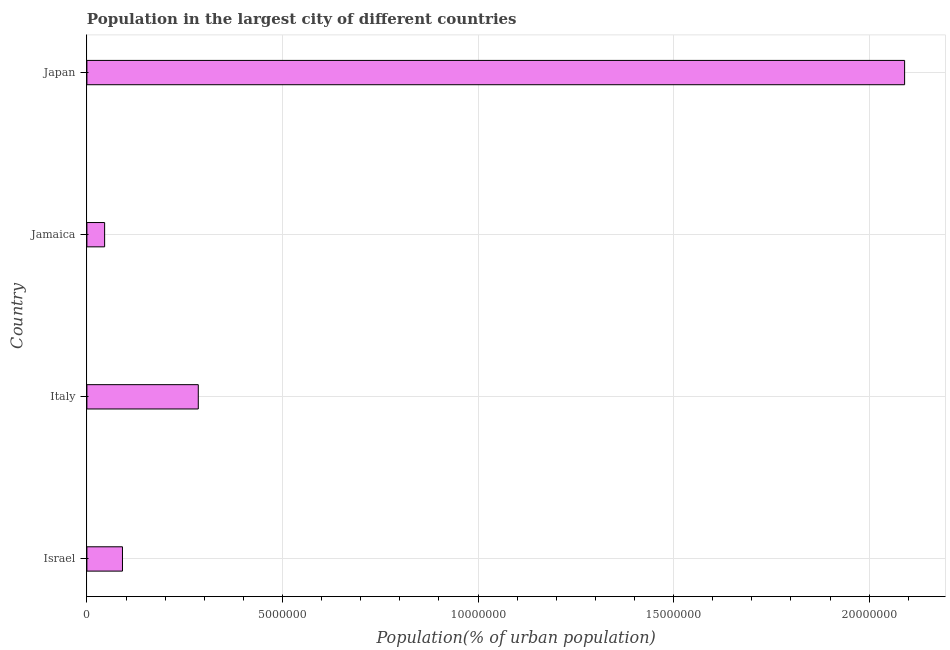Does the graph contain any zero values?
Provide a succinct answer. No. Does the graph contain grids?
Make the answer very short. Yes. What is the title of the graph?
Provide a short and direct response. Population in the largest city of different countries. What is the label or title of the X-axis?
Keep it short and to the point. Population(% of urban population). What is the population in largest city in Japan?
Offer a very short reply. 2.09e+07. Across all countries, what is the maximum population in largest city?
Your answer should be very brief. 2.09e+07. Across all countries, what is the minimum population in largest city?
Provide a short and direct response. 4.53e+05. In which country was the population in largest city maximum?
Make the answer very short. Japan. In which country was the population in largest city minimum?
Your response must be concise. Jamaica. What is the sum of the population in largest city?
Offer a very short reply. 2.51e+07. What is the difference between the population in largest city in Israel and Japan?
Your answer should be compact. -2.00e+07. What is the average population in largest city per country?
Provide a short and direct response. 6.28e+06. What is the median population in largest city?
Your answer should be compact. 1.88e+06. What is the ratio of the population in largest city in Jamaica to that in Japan?
Offer a very short reply. 0.02. What is the difference between the highest and the second highest population in largest city?
Offer a very short reply. 1.81e+07. Is the sum of the population in largest city in Italy and Jamaica greater than the maximum population in largest city across all countries?
Provide a succinct answer. No. What is the difference between the highest and the lowest population in largest city?
Offer a terse response. 2.05e+07. In how many countries, is the population in largest city greater than the average population in largest city taken over all countries?
Offer a terse response. 1. How many bars are there?
Provide a succinct answer. 4. Are all the bars in the graph horizontal?
Your answer should be compact. Yes. How many countries are there in the graph?
Make the answer very short. 4. What is the Population(% of urban population) in Israel?
Make the answer very short. 9.09e+05. What is the Population(% of urban population) in Italy?
Ensure brevity in your answer.  2.85e+06. What is the Population(% of urban population) of Jamaica?
Provide a short and direct response. 4.53e+05. What is the Population(% of urban population) in Japan?
Provide a short and direct response. 2.09e+07. What is the difference between the Population(% of urban population) in Israel and Italy?
Keep it short and to the point. -1.94e+06. What is the difference between the Population(% of urban population) in Israel and Jamaica?
Keep it short and to the point. 4.56e+05. What is the difference between the Population(% of urban population) in Israel and Japan?
Make the answer very short. -2.00e+07. What is the difference between the Population(% of urban population) in Italy and Jamaica?
Keep it short and to the point. 2.39e+06. What is the difference between the Population(% of urban population) in Italy and Japan?
Ensure brevity in your answer.  -1.81e+07. What is the difference between the Population(% of urban population) in Jamaica and Japan?
Ensure brevity in your answer.  -2.05e+07. What is the ratio of the Population(% of urban population) in Israel to that in Italy?
Make the answer very short. 0.32. What is the ratio of the Population(% of urban population) in Israel to that in Jamaica?
Your response must be concise. 2.01. What is the ratio of the Population(% of urban population) in Israel to that in Japan?
Your answer should be very brief. 0.04. What is the ratio of the Population(% of urban population) in Italy to that in Jamaica?
Give a very brief answer. 6.28. What is the ratio of the Population(% of urban population) in Italy to that in Japan?
Give a very brief answer. 0.14. What is the ratio of the Population(% of urban population) in Jamaica to that in Japan?
Offer a very short reply. 0.02. 